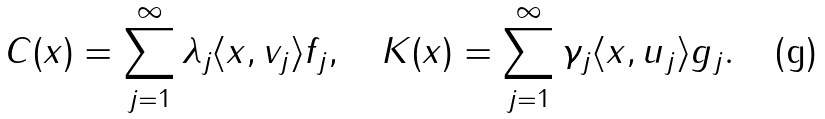Convert formula to latex. <formula><loc_0><loc_0><loc_500><loc_500>C ( x ) = \sum _ { j = 1 } ^ { \infty } \lambda _ { j } \langle x , v _ { j } \rangle f _ { j } , \quad K ( x ) = \sum _ { j = 1 } ^ { \infty } \gamma _ { j } \langle x , u _ { j } \rangle g _ { j } .</formula> 